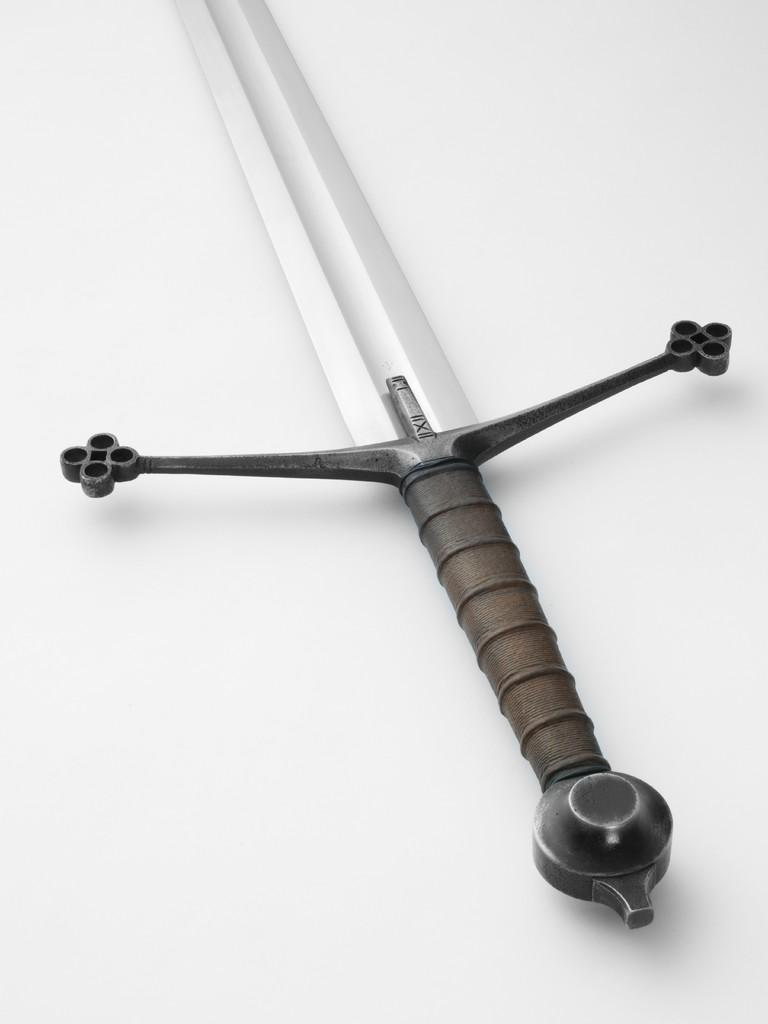What object can be seen in the image? There is a knife in the image. What colors does the knife have? The knife is white and black in color. On what surface is the knife placed? The knife is on a white colored surface. What type of card is being used to cut with the knife in the image? There is no card present in the image, and the knife is not being used to cut anything. 